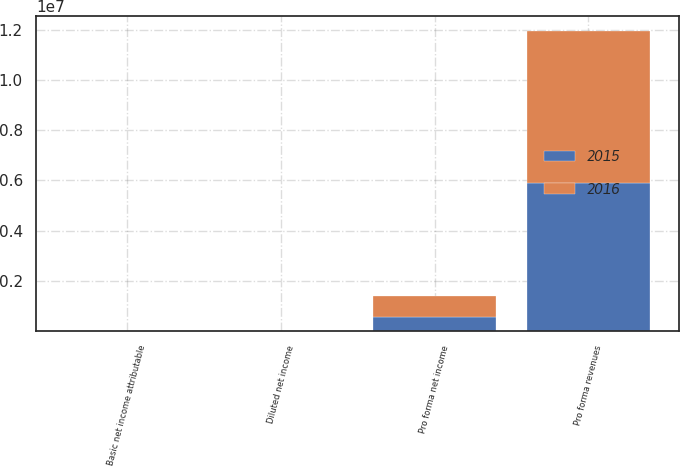Convert chart to OTSL. <chart><loc_0><loc_0><loc_500><loc_500><stacked_bar_chart><ecel><fcel>Pro forma revenues<fcel>Pro forma net income<fcel>Basic net income attributable<fcel>Diluted net income<nl><fcel>2016<fcel>6.05519e+06<fcel>847738<fcel>1.99<fcel>1.97<nl><fcel>2015<fcel>5.88669e+06<fcel>544641<fcel>1.29<fcel>1.27<nl></chart> 